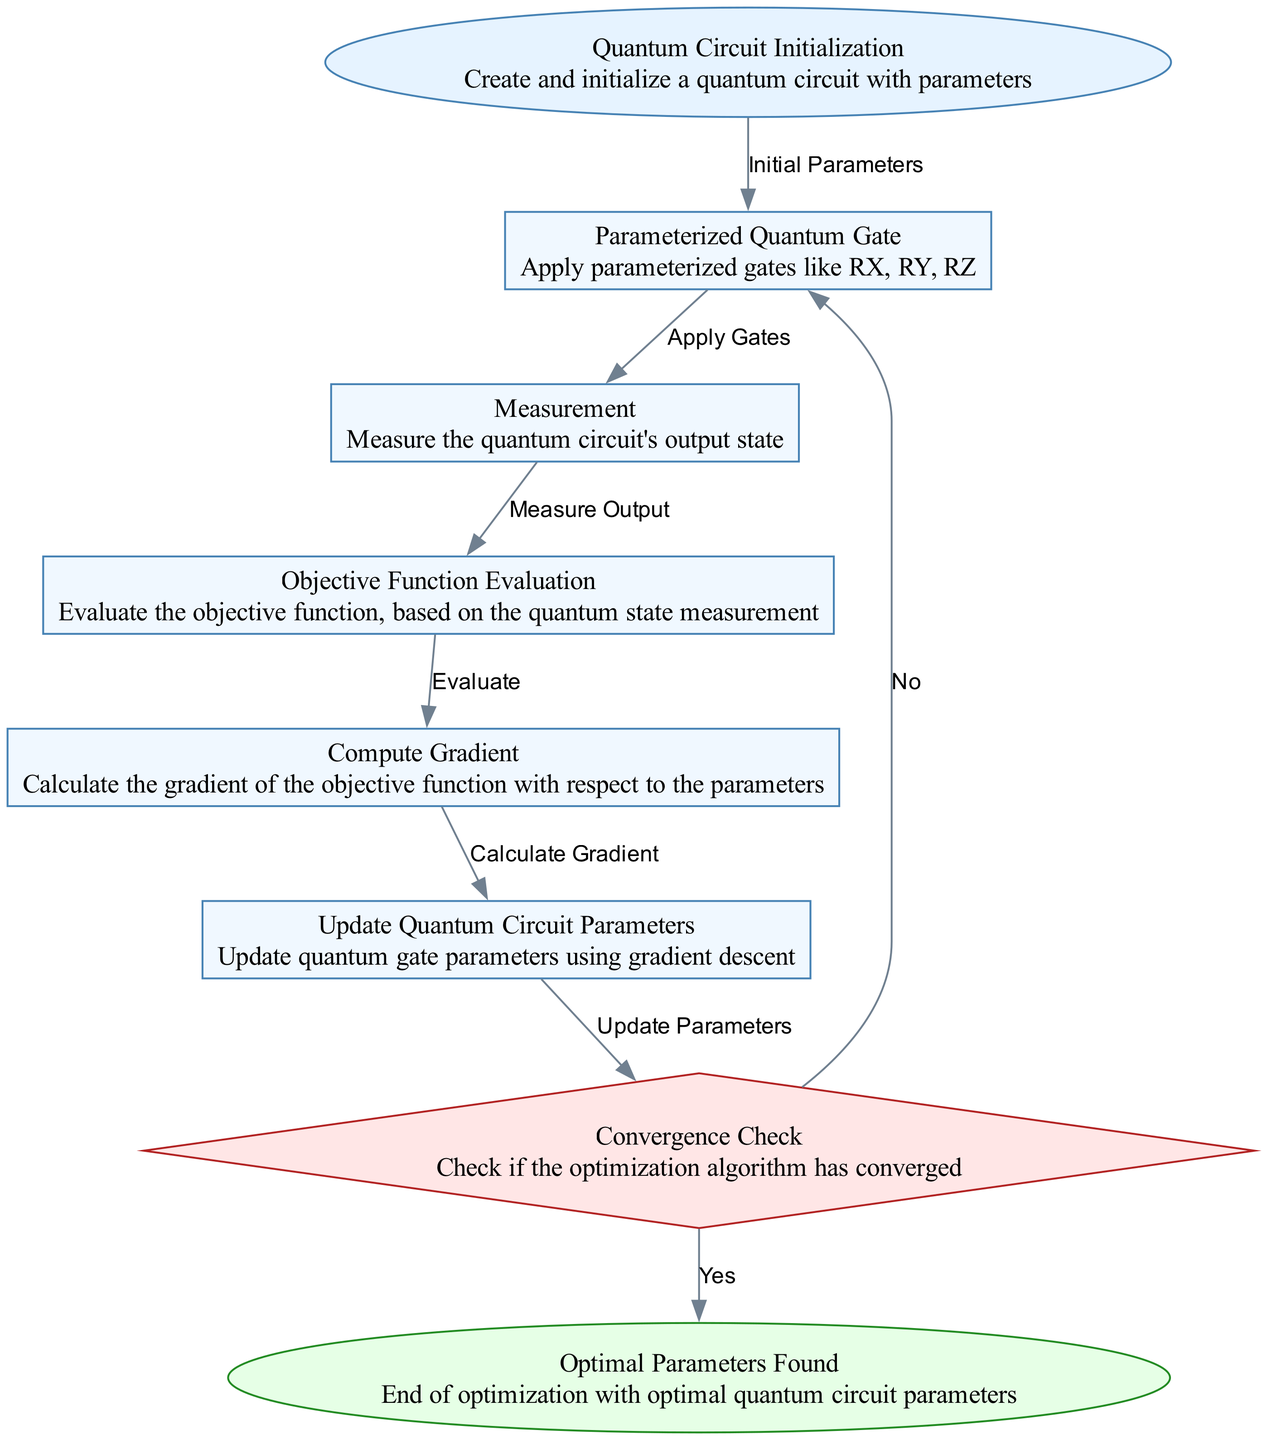What is the starting point of the optimization process? The diagram begins with the "Quantum Circuit Initialization" node, which indicates the initial step in the optimization process where the quantum circuit is created and initialized with parameters.
Answer: Quantum Circuit Initialization How many processes are involved in the optimization flow? The diagram consists of five processes: "Parameterized Quantum Gate," "Measurement," "Objective Function Evaluation," "Compute Gradient," and "Update Quantum Circuit Parameters." Counting these processes gives a total of five.
Answer: Five What decision needs to be made after updating quantum circuit parameters? After updating the quantum circuit parameters, the "Convergence Check" decision node is reached, where the optimization algorithm needs to determine if it has converged.
Answer: Convergence Check What happens if the optimization has not converged? If the optimization has not converged, the flow returns to the "Parameterized Quantum Gate" node to reapply the gates with updated parameters, allowing for further optimization iterations.
Answer: Apply Gates What is the final output of the optimization process? The final output corresponds to the "Optimal Parameters Found" node, indicating that the optimization has concluded successfully with the optimal parameters for the quantum circuit.
Answer: Optimal Parameters Found What is the relationship between "Compute Gradient" and "Update Quantum Circuit Parameters"? The "Compute Gradient" node directly leads to the "Update Quantum Circuit Parameters" node, indicating that after calculating the gradient of the objective function, the next step is to update the parameters based on this gradient.
Answer: Update Parameters 